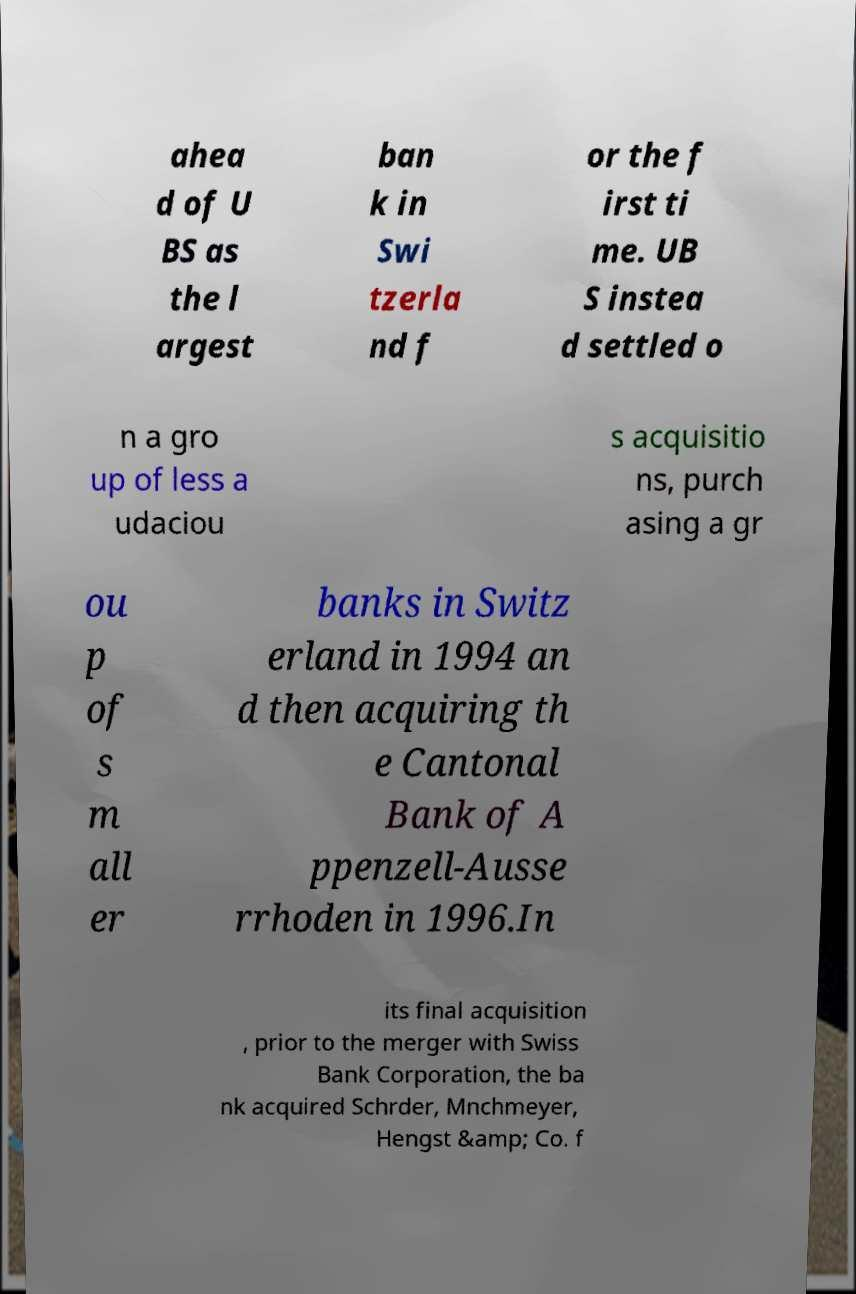I need the written content from this picture converted into text. Can you do that? ahea d of U BS as the l argest ban k in Swi tzerla nd f or the f irst ti me. UB S instea d settled o n a gro up of less a udaciou s acquisitio ns, purch asing a gr ou p of s m all er banks in Switz erland in 1994 an d then acquiring th e Cantonal Bank of A ppenzell-Ausse rrhoden in 1996.In its final acquisition , prior to the merger with Swiss Bank Corporation, the ba nk acquired Schrder, Mnchmeyer, Hengst &amp; Co. f 